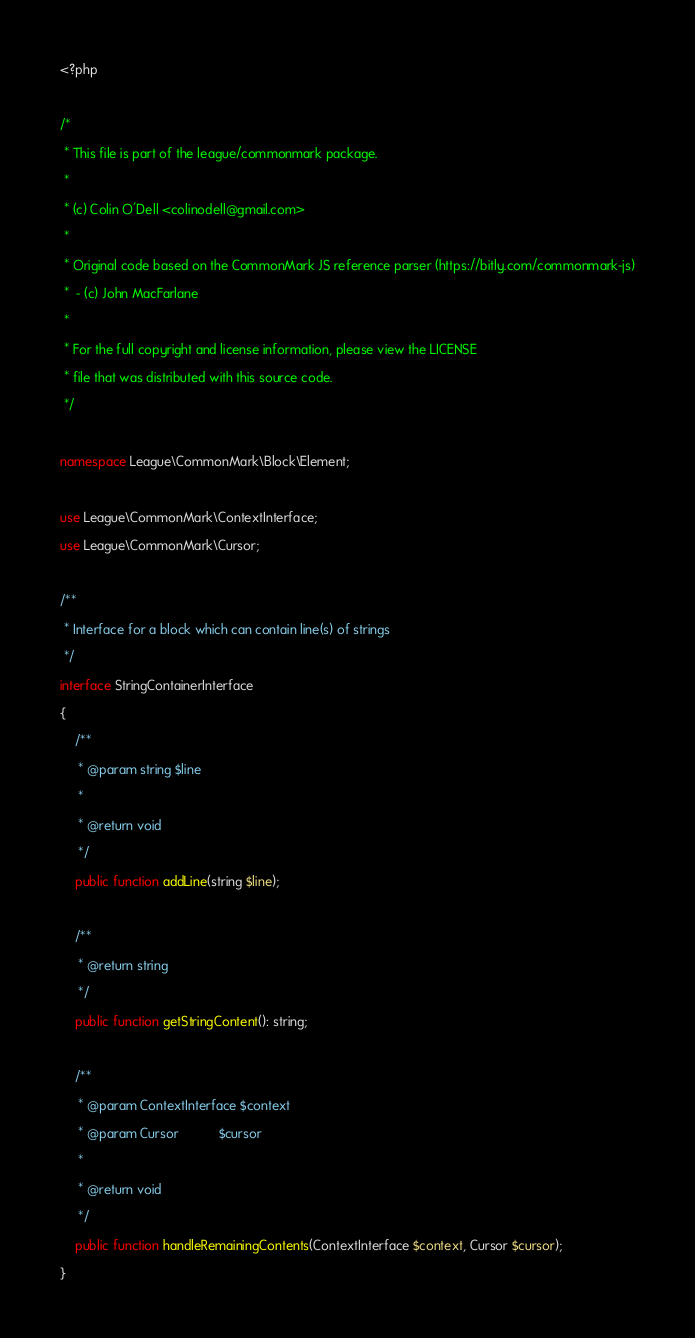<code> <loc_0><loc_0><loc_500><loc_500><_PHP_><?php

/*
 * This file is part of the league/commonmark package.
 *
 * (c) Colin O'Dell <colinodell@gmail.com>
 *
 * Original code based on the CommonMark JS reference parser (https://bitly.com/commonmark-js)
 *  - (c) John MacFarlane
 *
 * For the full copyright and license information, please view the LICENSE
 * file that was distributed with this source code.
 */

namespace League\CommonMark\Block\Element;

use League\CommonMark\ContextInterface;
use League\CommonMark\Cursor;

/**
 * Interface for a block which can contain line(s) of strings
 */
interface StringContainerInterface
{
    /**
     * @param string $line
     *
     * @return void
     */
    public function addLine(string $line);

    /**
     * @return string
     */
    public function getStringContent(): string;

    /**
     * @param ContextInterface $context
     * @param Cursor           $cursor
     *
     * @return void
     */
    public function handleRemainingContents(ContextInterface $context, Cursor $cursor);
}
</code> 